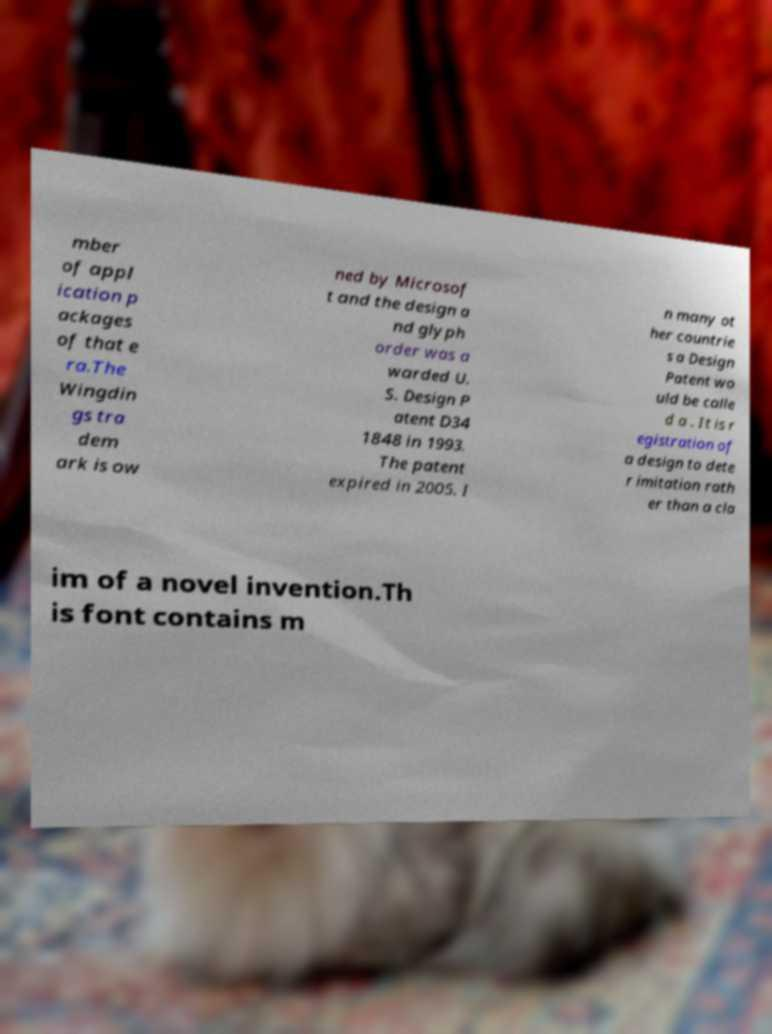Could you extract and type out the text from this image? mber of appl ication p ackages of that e ra.The Wingdin gs tra dem ark is ow ned by Microsof t and the design a nd glyph order was a warded U. S. Design P atent D34 1848 in 1993. The patent expired in 2005. I n many ot her countrie s a Design Patent wo uld be calle d a . It is r egistration of a design to dete r imitation rath er than a cla im of a novel invention.Th is font contains m 